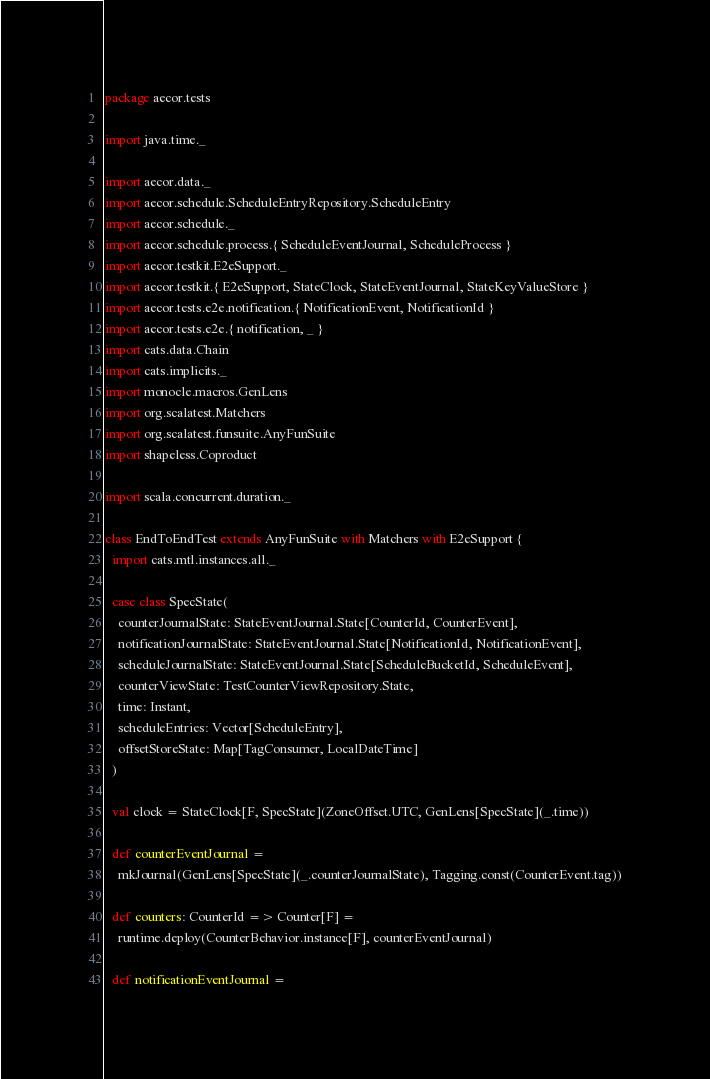Convert code to text. <code><loc_0><loc_0><loc_500><loc_500><_Scala_>package aecor.tests

import java.time._

import aecor.data._
import aecor.schedule.ScheduleEntryRepository.ScheduleEntry
import aecor.schedule._
import aecor.schedule.process.{ ScheduleEventJournal, ScheduleProcess }
import aecor.testkit.E2eSupport._
import aecor.testkit.{ E2eSupport, StateClock, StateEventJournal, StateKeyValueStore }
import aecor.tests.e2e.notification.{ NotificationEvent, NotificationId }
import aecor.tests.e2e.{ notification, _ }
import cats.data.Chain
import cats.implicits._
import monocle.macros.GenLens
import org.scalatest.Matchers
import org.scalatest.funsuite.AnyFunSuite
import shapeless.Coproduct

import scala.concurrent.duration._

class EndToEndTest extends AnyFunSuite with Matchers with E2eSupport {
  import cats.mtl.instances.all._

  case class SpecState(
    counterJournalState: StateEventJournal.State[CounterId, CounterEvent],
    notificationJournalState: StateEventJournal.State[NotificationId, NotificationEvent],
    scheduleJournalState: StateEventJournal.State[ScheduleBucketId, ScheduleEvent],
    counterViewState: TestCounterViewRepository.State,
    time: Instant,
    scheduleEntries: Vector[ScheduleEntry],
    offsetStoreState: Map[TagConsumer, LocalDateTime]
  )

  val clock = StateClock[F, SpecState](ZoneOffset.UTC, GenLens[SpecState](_.time))

  def counterEventJournal =
    mkJournal(GenLens[SpecState](_.counterJournalState), Tagging.const(CounterEvent.tag))

  def counters: CounterId => Counter[F] =
    runtime.deploy(CounterBehavior.instance[F], counterEventJournal)

  def notificationEventJournal =</code> 